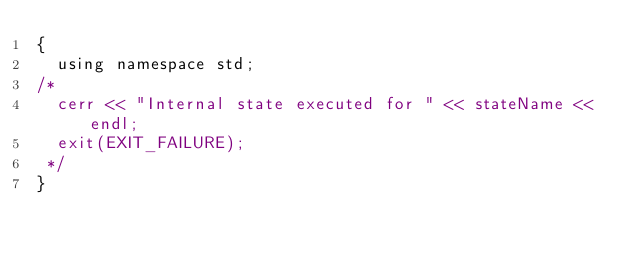<code> <loc_0><loc_0><loc_500><loc_500><_ObjectiveC_>{
  using namespace std;
/*
  cerr << "Internal state executed for " << stateName << endl;
  exit(EXIT_FAILURE);
 */
}
</code> 